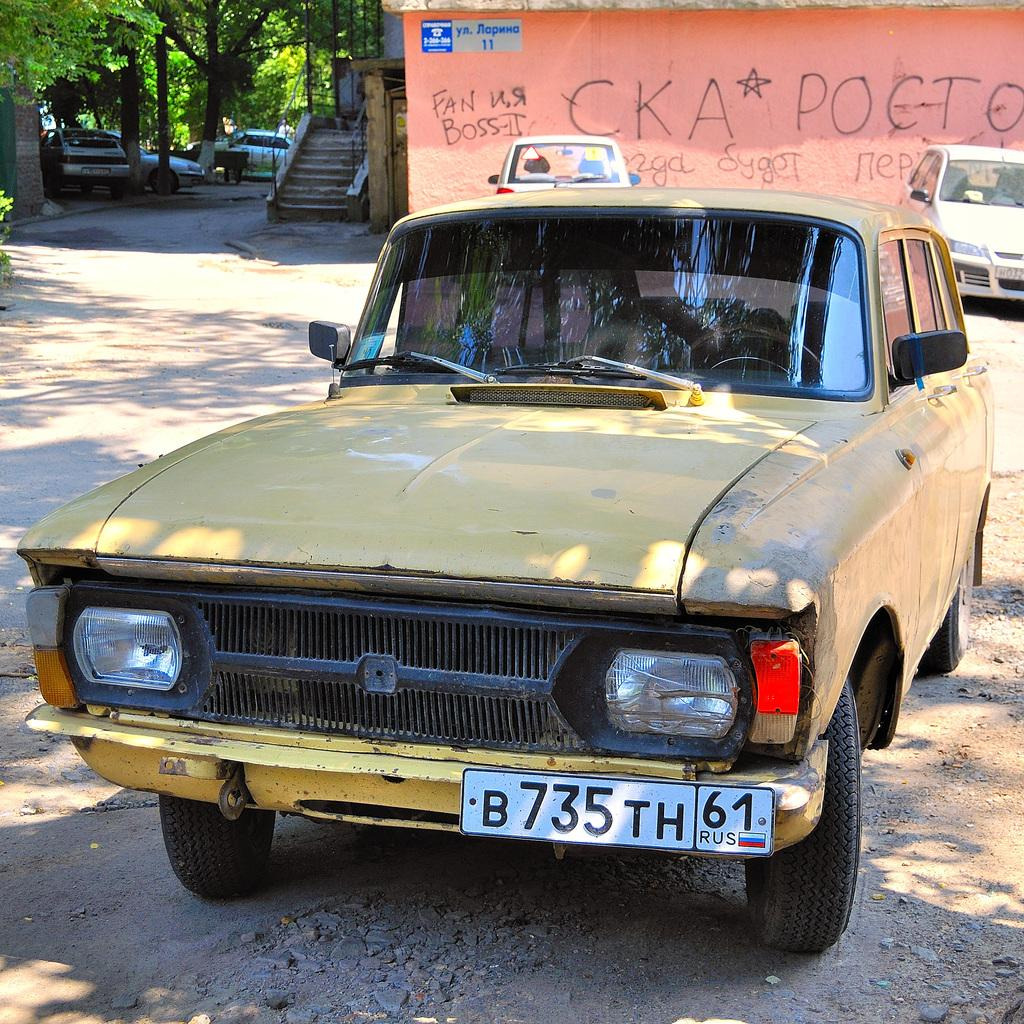<image>
Summarize the visual content of the image. A yellow taxi is parked in a dirt lot by a pink building with graffiti that says CKA Pocto. 